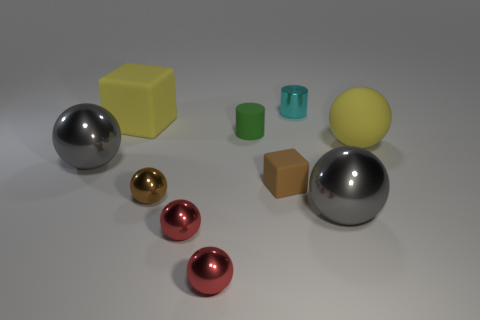Subtract all brown balls. How many balls are left? 5 Subtract all green cylinders. How many cylinders are left? 1 Subtract 6 balls. How many balls are left? 0 Subtract all spheres. How many objects are left? 4 Subtract all brown cubes. How many purple balls are left? 0 Subtract all large yellow balls. Subtract all large blocks. How many objects are left? 8 Add 5 tiny brown shiny spheres. How many tiny brown shiny spheres are left? 6 Add 2 small red metallic spheres. How many small red metallic spheres exist? 4 Subtract 0 gray cylinders. How many objects are left? 10 Subtract all brown blocks. Subtract all brown balls. How many blocks are left? 1 